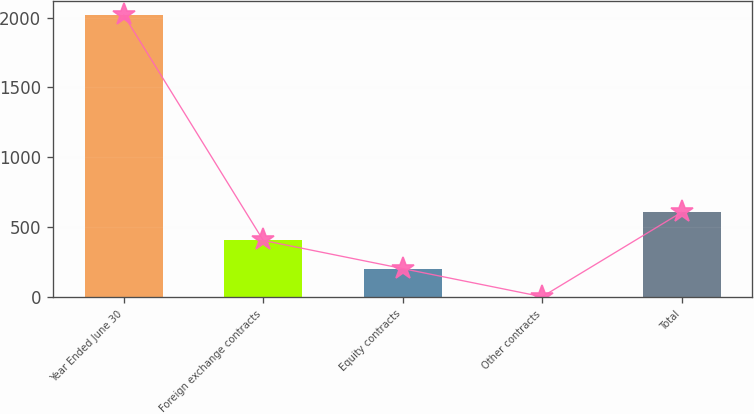<chart> <loc_0><loc_0><loc_500><loc_500><bar_chart><fcel>Year Ended June 30<fcel>Foreign exchange contracts<fcel>Equity contracts<fcel>Other contracts<fcel>Total<nl><fcel>2017<fcel>405.8<fcel>204.4<fcel>3<fcel>607.2<nl></chart> 